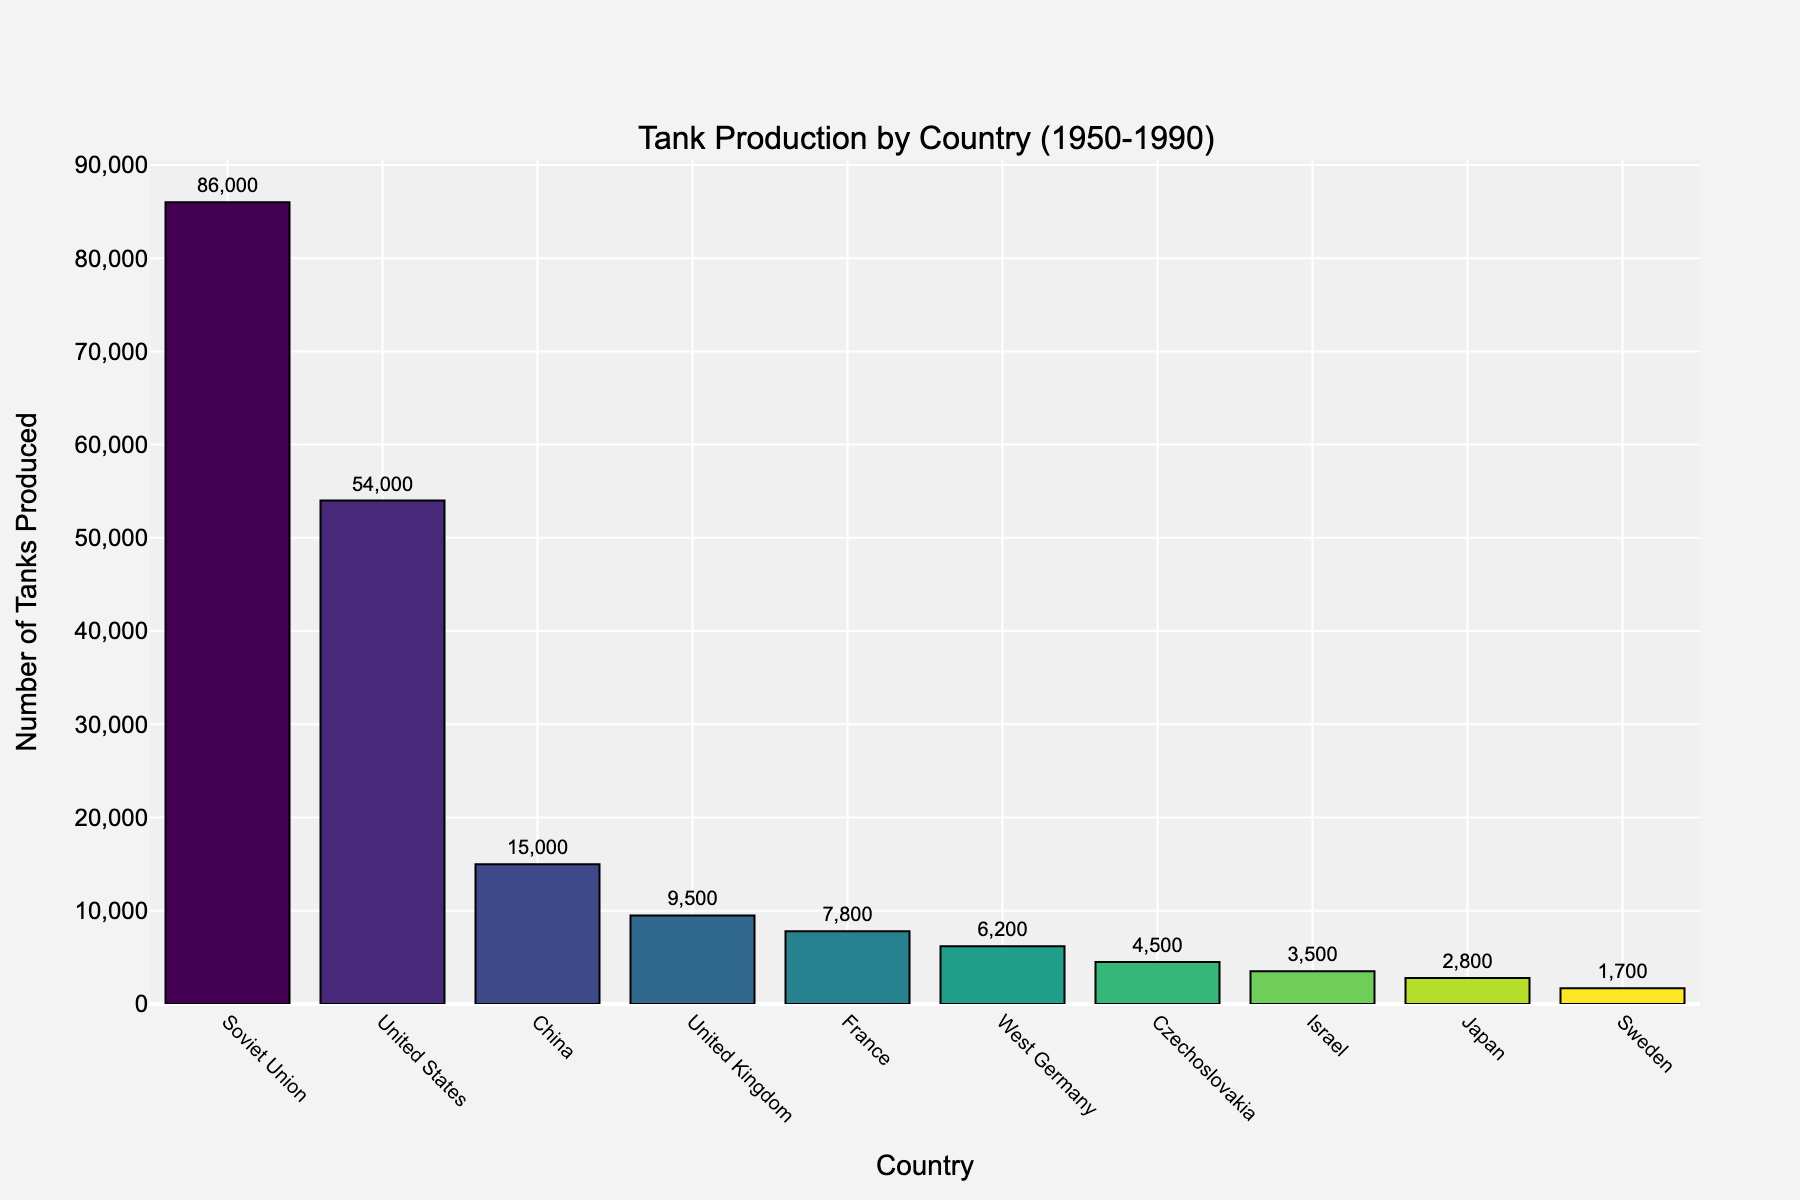Which country produced the most tanks? The bar for the Soviet Union is the tallest, which indicates the highest production number.
Answer: Soviet Union How many more tanks did the Soviet Union produce compared to the United States? The Soviet Union produced 86,000 tanks and the United States produced 54,000 tanks. The difference is 86,000 - 54,000.
Answer: 32,000 Which two countries have the smallest difference in tank production? Comparing the production numbers, Sweden (1,700) and Czechoslovakia (4,500) have a difference of 2,800; other closer pairs include France (7,800) and the United Kingdom (9,500) with a difference of 1,700. The smallest is between France and the United Kingdom.
Answer: France and United Kingdom What is the total tank production of all countries combined? Summing all the production numbers: 54,000 + 86,000 + 9,500 + 7,800 + 6,200 + 15,000 + 3,500 + 2,800 + 1,700 + 4,500.
Answer: 191,000 How does the height of China’s bar compare to that of France? Visually, China's bar (15,000) is about twice as high as France's bar (7,800).
Answer: Approximately twice as high Which country had lower production, Japan or Israel, and by how much? Israel produced 3,500 tanks while Japan produced 2,800 tanks. The difference is 3,500 - 2,800.
Answer: Japan by 700 tanks Rank the countries by tank production from highest to lowest. Based on the bar heights and numerical values: Soviet Union, United States, China, United Kingdom, France, West Germany, Czechoslovakia, Israel, Japan, Sweden.
Answer: Soviet Union, United States, China, United Kingdom, France, West Germany, Czechoslovakia, Israel, Japan, Sweden Is the total production of West Germany and Japan higher than that of the United Kingdom? Summing West Germany (6,200) and Japan (2,800) gives 9,000. The United Kingdom produced 9,500 tanks.
Answer: No 